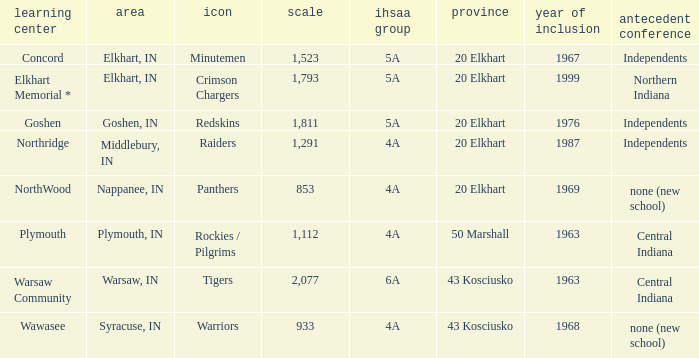What is the size of the team that was previously from Central Indiana conference, and is in IHSSA Class 4a? 1112.0. 